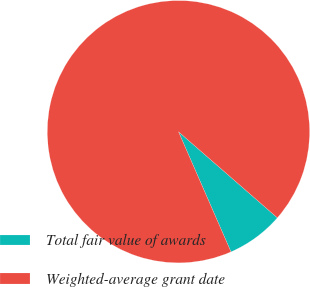Convert chart to OTSL. <chart><loc_0><loc_0><loc_500><loc_500><pie_chart><fcel>Total fair value of awards<fcel>Weighted-average grant date<nl><fcel>7.04%<fcel>92.96%<nl></chart> 